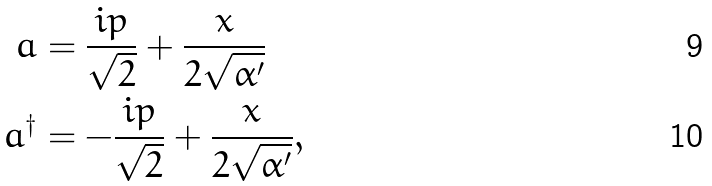<formula> <loc_0><loc_0><loc_500><loc_500>a & = \frac { i p } { \sqrt { 2 } } + \frac { x } { 2 \sqrt { \alpha ^ { \prime } } } \\ a ^ { \dag } & = - \frac { i p } { \sqrt { 2 } } + \frac { x } { 2 \sqrt { \alpha ^ { \prime } } } ,</formula> 